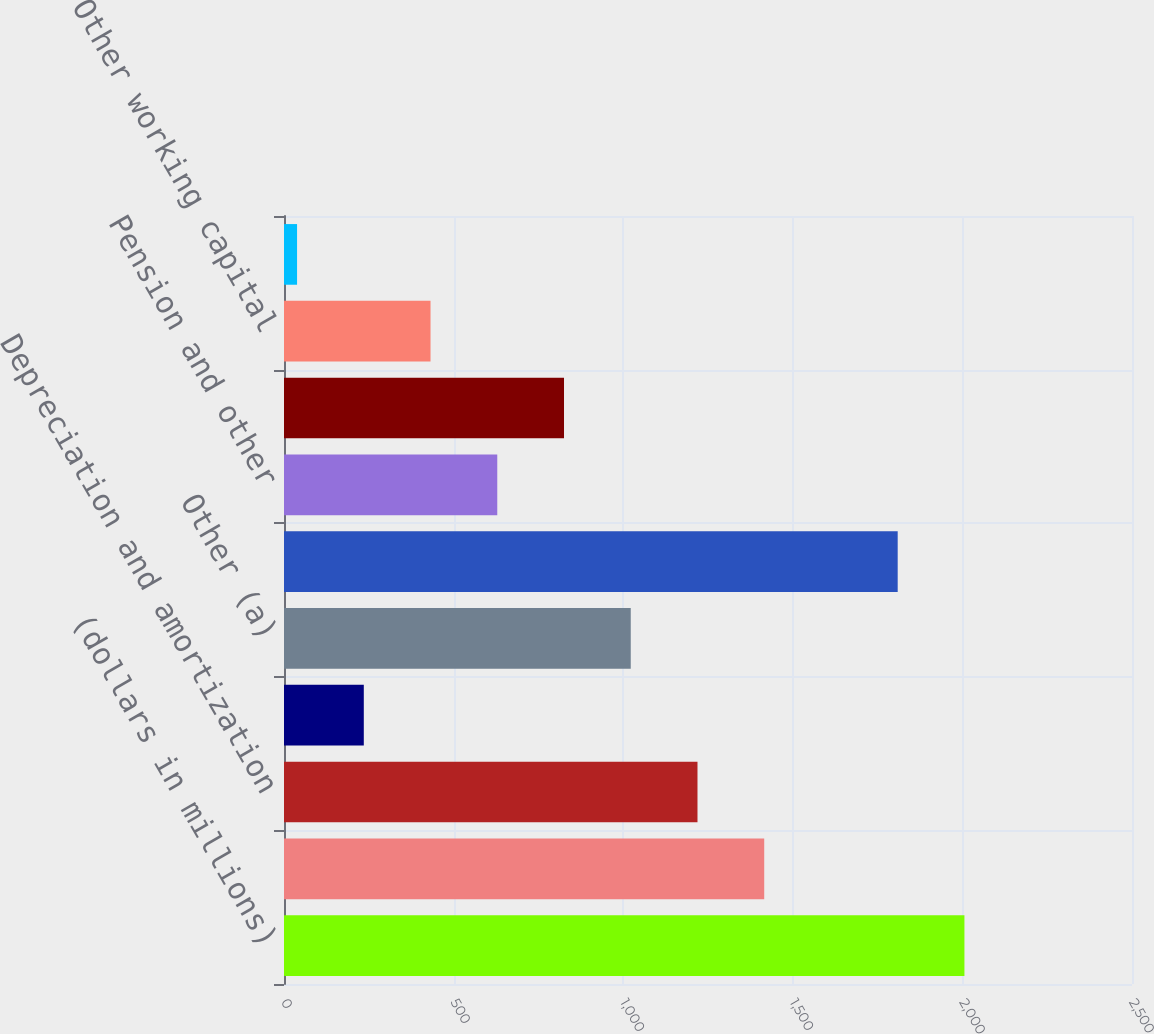Convert chart. <chart><loc_0><loc_0><loc_500><loc_500><bar_chart><fcel>(dollars in millions)<fcel>Net earnings<fcel>Depreciation and amortization<fcel>Deferred income taxes<fcel>Other (a)<fcel>Net earnings after non-cash<fcel>Pension and other<fcel>Core working capital (b)<fcel>Other working capital<fcel>Total<nl><fcel>2006<fcel>1415.75<fcel>1219<fcel>235.25<fcel>1022.25<fcel>1809.25<fcel>628.75<fcel>825.5<fcel>432<fcel>38.5<nl></chart> 